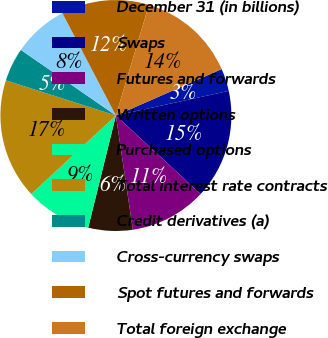<chart> <loc_0><loc_0><loc_500><loc_500><pie_chart><fcel>December 31 (in billions)<fcel>Swaps<fcel>Futures and forwards<fcel>Written options<fcel>Purchased options<fcel>Total interest rate contracts<fcel>Credit derivatives (a)<fcel>Cross-currency swaps<fcel>Spot futures and forwards<fcel>Total foreign exchange<nl><fcel>3.17%<fcel>15.31%<fcel>10.76%<fcel>6.2%<fcel>9.24%<fcel>16.83%<fcel>4.69%<fcel>7.72%<fcel>12.28%<fcel>13.8%<nl></chart> 